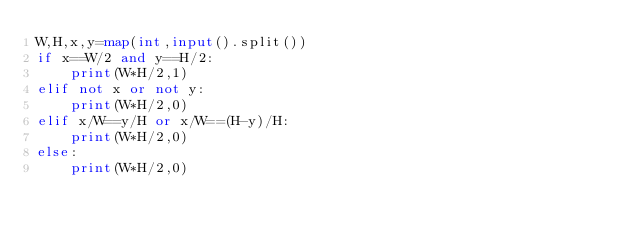<code> <loc_0><loc_0><loc_500><loc_500><_Python_>W,H,x,y=map(int,input().split())
if x==W/2 and y==H/2:
    print(W*H/2,1)
elif not x or not y:
    print(W*H/2,0)
elif x/W==y/H or x/W==(H-y)/H:
    print(W*H/2,0)
else:
    print(W*H/2,0)
</code> 